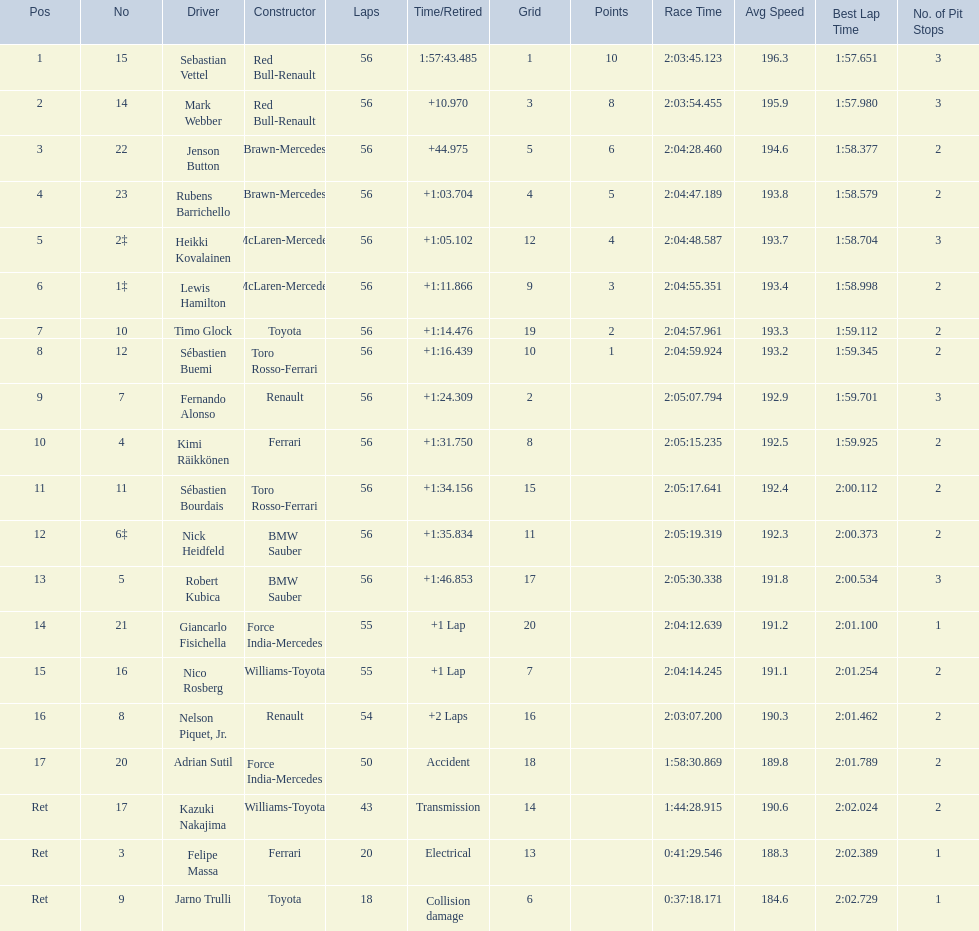Who are all the drivers? Sebastian Vettel, Mark Webber, Jenson Button, Rubens Barrichello, Heikki Kovalainen, Lewis Hamilton, Timo Glock, Sébastien Buemi, Fernando Alonso, Kimi Räikkönen, Sébastien Bourdais, Nick Heidfeld, Robert Kubica, Giancarlo Fisichella, Nico Rosberg, Nelson Piquet, Jr., Adrian Sutil, Kazuki Nakajima, Felipe Massa, Jarno Trulli. What were their finishing times? 1:57:43.485, +10.970, +44.975, +1:03.704, +1:05.102, +1:11.866, +1:14.476, +1:16.439, +1:24.309, +1:31.750, +1:34.156, +1:35.834, +1:46.853, +1 Lap, +1 Lap, +2 Laps, Accident, Transmission, Electrical, Collision damage. Write the full table. {'header': ['Pos', 'No', 'Driver', 'Constructor', 'Laps', 'Time/Retired', 'Grid', 'Points', 'Race Time', 'Avg Speed', 'Best Lap Time', 'No. of Pit Stops'], 'rows': [['1', '15', 'Sebastian Vettel', 'Red Bull-Renault', '56', '1:57:43.485', '1', '10', '2:03:45.123', '196.3', '1:57.651', '3'], ['2', '14', 'Mark Webber', 'Red Bull-Renault', '56', '+10.970', '3', '8', '2:03:54.455', '195.9', '1:57.980', '3'], ['3', '22', 'Jenson Button', 'Brawn-Mercedes', '56', '+44.975', '5', '6', '2:04:28.460', '194.6', '1:58.377', '2'], ['4', '23', 'Rubens Barrichello', 'Brawn-Mercedes', '56', '+1:03.704', '4', '5', '2:04:47.189', '193.8', '1:58.579', '2'], ['5', '2‡', 'Heikki Kovalainen', 'McLaren-Mercedes', '56', '+1:05.102', '12', '4', '2:04:48.587', '193.7', '1:58.704', '3'], ['6', '1‡', 'Lewis Hamilton', 'McLaren-Mercedes', '56', '+1:11.866', '9', '3', '2:04:55.351', '193.4', '1:58.998', '2'], ['7', '10', 'Timo Glock', 'Toyota', '56', '+1:14.476', '19', '2', '2:04:57.961', '193.3', '1:59.112', '2'], ['8', '12', 'Sébastien Buemi', 'Toro Rosso-Ferrari', '56', '+1:16.439', '10', '1', '2:04:59.924', '193.2', '1:59.345', '2'], ['9', '7', 'Fernando Alonso', 'Renault', '56', '+1:24.309', '2', '', '2:05:07.794', '192.9', '1:59.701', '3'], ['10', '4', 'Kimi Räikkönen', 'Ferrari', '56', '+1:31.750', '8', '', '2:05:15.235', '192.5', '1:59.925', '2'], ['11', '11', 'Sébastien Bourdais', 'Toro Rosso-Ferrari', '56', '+1:34.156', '15', '', '2:05:17.641', '192.4', '2:00.112', '2'], ['12', '6‡', 'Nick Heidfeld', 'BMW Sauber', '56', '+1:35.834', '11', '', '2:05:19.319', '192.3', '2:00.373', '2'], ['13', '5', 'Robert Kubica', 'BMW Sauber', '56', '+1:46.853', '17', '', '2:05:30.338', '191.8', '2:00.534', '3'], ['14', '21', 'Giancarlo Fisichella', 'Force India-Mercedes', '55', '+1 Lap', '20', '', '2:04:12.639', '191.2', '2:01.100', '1'], ['15', '16', 'Nico Rosberg', 'Williams-Toyota', '55', '+1 Lap', '7', '', '2:04:14.245', '191.1', '2:01.254', '2'], ['16', '8', 'Nelson Piquet, Jr.', 'Renault', '54', '+2 Laps', '16', '', '2:03:07.200', '190.3', '2:01.462', '2'], ['17', '20', 'Adrian Sutil', 'Force India-Mercedes', '50', 'Accident', '18', '', '1:58:30.869', '189.8', '2:01.789', '2'], ['Ret', '17', 'Kazuki Nakajima', 'Williams-Toyota', '43', 'Transmission', '14', '', '1:44:28.915', '190.6', '2:02.024', '2'], ['Ret', '3', 'Felipe Massa', 'Ferrari', '20', 'Electrical', '13', '', '0:41:29.546', '188.3', '2:02.389', '1'], ['Ret', '9', 'Jarno Trulli', 'Toyota', '18', 'Collision damage', '6', '', '0:37:18.171', '184.6', '2:02.729', '1']]} Who finished last? Robert Kubica. 